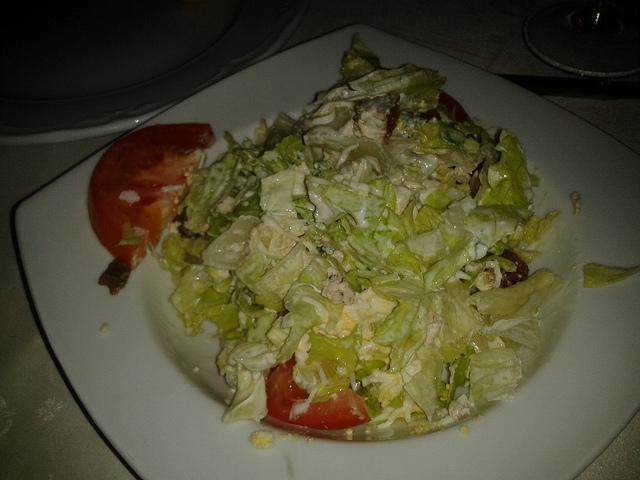Is this meal from someone's home or from a store?
Short answer required. Home. What is the green food called?
Short answer required. Lettuce. What is the green object shown?
Give a very brief answer. Lettuce. Does the meal look delicious?
Short answer required. No. Is there asparagus in this picture?
Answer briefly. No. What is the green stuff on the plate?
Give a very brief answer. Lettuce. Is the meal delicious?
Concise answer only. Yes. Is this chinese?
Keep it brief. No. Does the salad have dressing?
Keep it brief. Yes. Do this look yummy?
Answer briefly. Yes. Would a vegan eat this?
Write a very short answer. Yes. Are there tomatoes in the salad?
Write a very short answer. Yes. Is there fish on the plate?
Quick response, please. No. Would you call this a vegetable salad?
Give a very brief answer. Yes. What food is pictured here?
Write a very short answer. Salad. What is the dominant food on this plate?
Write a very short answer. Lettuce. Is this a morning meal?
Answer briefly. No. Could a vegetarian eat this meal?
Be succinct. Yes. What type of salad is that?
Keep it brief. Caesar. What piece of food is green?
Write a very short answer. Lettuce. Is this meal vegetarian?
Quick response, please. Yes. What vegetable fills the plate?
Concise answer only. Lettuce. Is this broccoli?
Write a very short answer. No. What is the green stuff?
Concise answer only. Lettuce. What vegetables are on the plate?
Keep it brief. Lettuce. Is visual acuity promoted by this dish?
Concise answer only. No. What types of food are on the orange plate?
Write a very short answer. Salad. Is the food tasty?
Give a very brief answer. No. What is on the vegetable?
Be succinct. Dressing. What is the main ingredient in this food dish?
Concise answer only. Lettuce. What kind of salad is that?
Answer briefly. Chef. Is this a vegetarian meal?
Write a very short answer. Yes. Where is the corn?
Concise answer only. In salad. Is there protein on the plate?
Answer briefly. No. What are green vegetables?
Be succinct. Lettuce. What pattern is the tablecloth?
Short answer required. Flowers. Is this meal being served indoors?
Concise answer only. Yes. 